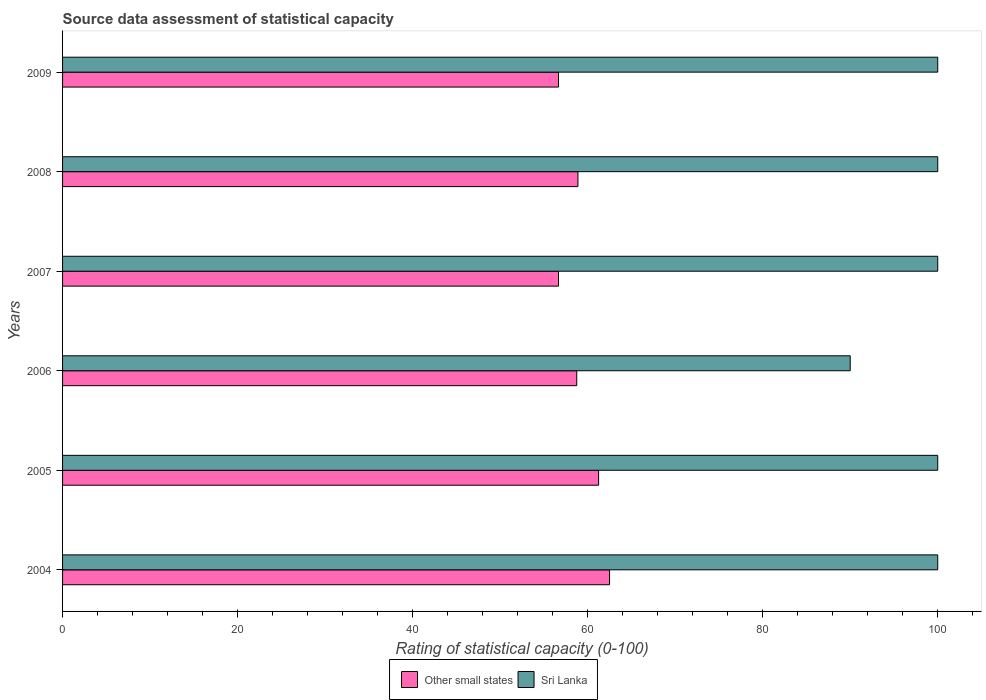How many different coloured bars are there?
Offer a very short reply. 2. How many groups of bars are there?
Your answer should be compact. 6. Are the number of bars per tick equal to the number of legend labels?
Provide a succinct answer. Yes. Are the number of bars on each tick of the Y-axis equal?
Offer a very short reply. Yes. In how many cases, is the number of bars for a given year not equal to the number of legend labels?
Your response must be concise. 0. What is the rating of statistical capacity in Sri Lanka in 2008?
Make the answer very short. 100. Across all years, what is the maximum rating of statistical capacity in Sri Lanka?
Ensure brevity in your answer.  100. Across all years, what is the minimum rating of statistical capacity in Other small states?
Keep it short and to the point. 56.67. What is the total rating of statistical capacity in Sri Lanka in the graph?
Offer a terse response. 590. What is the difference between the rating of statistical capacity in Other small states in 2008 and that in 2009?
Keep it short and to the point. 2.22. What is the difference between the rating of statistical capacity in Sri Lanka in 2006 and the rating of statistical capacity in Other small states in 2009?
Make the answer very short. 33.33. What is the average rating of statistical capacity in Other small states per year?
Your response must be concise. 59.12. In the year 2006, what is the difference between the rating of statistical capacity in Sri Lanka and rating of statistical capacity in Other small states?
Your answer should be compact. 31.25. In how many years, is the rating of statistical capacity in Other small states greater than 20 ?
Make the answer very short. 6. Is the rating of statistical capacity in Other small states in 2007 less than that in 2009?
Offer a very short reply. No. What is the difference between the highest and the lowest rating of statistical capacity in Sri Lanka?
Give a very brief answer. 10. In how many years, is the rating of statistical capacity in Sri Lanka greater than the average rating of statistical capacity in Sri Lanka taken over all years?
Make the answer very short. 5. Is the sum of the rating of statistical capacity in Sri Lanka in 2006 and 2008 greater than the maximum rating of statistical capacity in Other small states across all years?
Keep it short and to the point. Yes. What does the 2nd bar from the top in 2005 represents?
Your response must be concise. Other small states. What does the 2nd bar from the bottom in 2005 represents?
Your response must be concise. Sri Lanka. How many bars are there?
Give a very brief answer. 12. Are the values on the major ticks of X-axis written in scientific E-notation?
Your response must be concise. No. Where does the legend appear in the graph?
Your answer should be very brief. Bottom center. How many legend labels are there?
Keep it short and to the point. 2. What is the title of the graph?
Your response must be concise. Source data assessment of statistical capacity. Does "Sub-Saharan Africa (all income levels)" appear as one of the legend labels in the graph?
Keep it short and to the point. No. What is the label or title of the X-axis?
Offer a terse response. Rating of statistical capacity (0-100). What is the label or title of the Y-axis?
Offer a very short reply. Years. What is the Rating of statistical capacity (0-100) in Other small states in 2004?
Ensure brevity in your answer.  62.5. What is the Rating of statistical capacity (0-100) in Other small states in 2005?
Offer a terse response. 61.25. What is the Rating of statistical capacity (0-100) in Sri Lanka in 2005?
Your answer should be compact. 100. What is the Rating of statistical capacity (0-100) in Other small states in 2006?
Offer a very short reply. 58.75. What is the Rating of statistical capacity (0-100) of Sri Lanka in 2006?
Keep it short and to the point. 90. What is the Rating of statistical capacity (0-100) of Other small states in 2007?
Provide a succinct answer. 56.67. What is the Rating of statistical capacity (0-100) of Sri Lanka in 2007?
Keep it short and to the point. 100. What is the Rating of statistical capacity (0-100) in Other small states in 2008?
Your answer should be compact. 58.89. What is the Rating of statistical capacity (0-100) of Other small states in 2009?
Your answer should be very brief. 56.67. Across all years, what is the maximum Rating of statistical capacity (0-100) of Other small states?
Offer a terse response. 62.5. Across all years, what is the maximum Rating of statistical capacity (0-100) of Sri Lanka?
Make the answer very short. 100. Across all years, what is the minimum Rating of statistical capacity (0-100) of Other small states?
Your answer should be compact. 56.67. What is the total Rating of statistical capacity (0-100) in Other small states in the graph?
Offer a very short reply. 354.72. What is the total Rating of statistical capacity (0-100) of Sri Lanka in the graph?
Provide a short and direct response. 590. What is the difference between the Rating of statistical capacity (0-100) in Other small states in 2004 and that in 2006?
Offer a very short reply. 3.75. What is the difference between the Rating of statistical capacity (0-100) in Other small states in 2004 and that in 2007?
Make the answer very short. 5.83. What is the difference between the Rating of statistical capacity (0-100) of Sri Lanka in 2004 and that in 2007?
Keep it short and to the point. 0. What is the difference between the Rating of statistical capacity (0-100) of Other small states in 2004 and that in 2008?
Offer a very short reply. 3.61. What is the difference between the Rating of statistical capacity (0-100) in Sri Lanka in 2004 and that in 2008?
Provide a short and direct response. 0. What is the difference between the Rating of statistical capacity (0-100) in Other small states in 2004 and that in 2009?
Offer a very short reply. 5.83. What is the difference between the Rating of statistical capacity (0-100) of Sri Lanka in 2004 and that in 2009?
Offer a very short reply. 0. What is the difference between the Rating of statistical capacity (0-100) of Other small states in 2005 and that in 2006?
Provide a short and direct response. 2.5. What is the difference between the Rating of statistical capacity (0-100) in Sri Lanka in 2005 and that in 2006?
Your answer should be compact. 10. What is the difference between the Rating of statistical capacity (0-100) in Other small states in 2005 and that in 2007?
Offer a very short reply. 4.58. What is the difference between the Rating of statistical capacity (0-100) of Sri Lanka in 2005 and that in 2007?
Your answer should be compact. 0. What is the difference between the Rating of statistical capacity (0-100) in Other small states in 2005 and that in 2008?
Make the answer very short. 2.36. What is the difference between the Rating of statistical capacity (0-100) in Other small states in 2005 and that in 2009?
Provide a succinct answer. 4.58. What is the difference between the Rating of statistical capacity (0-100) of Other small states in 2006 and that in 2007?
Give a very brief answer. 2.08. What is the difference between the Rating of statistical capacity (0-100) in Other small states in 2006 and that in 2008?
Give a very brief answer. -0.14. What is the difference between the Rating of statistical capacity (0-100) of Sri Lanka in 2006 and that in 2008?
Ensure brevity in your answer.  -10. What is the difference between the Rating of statistical capacity (0-100) in Other small states in 2006 and that in 2009?
Offer a terse response. 2.08. What is the difference between the Rating of statistical capacity (0-100) of Sri Lanka in 2006 and that in 2009?
Offer a terse response. -10. What is the difference between the Rating of statistical capacity (0-100) in Other small states in 2007 and that in 2008?
Ensure brevity in your answer.  -2.22. What is the difference between the Rating of statistical capacity (0-100) in Sri Lanka in 2007 and that in 2009?
Your answer should be very brief. 0. What is the difference between the Rating of statistical capacity (0-100) of Other small states in 2008 and that in 2009?
Give a very brief answer. 2.22. What is the difference between the Rating of statistical capacity (0-100) in Sri Lanka in 2008 and that in 2009?
Give a very brief answer. 0. What is the difference between the Rating of statistical capacity (0-100) in Other small states in 2004 and the Rating of statistical capacity (0-100) in Sri Lanka in 2005?
Your answer should be very brief. -37.5. What is the difference between the Rating of statistical capacity (0-100) in Other small states in 2004 and the Rating of statistical capacity (0-100) in Sri Lanka in 2006?
Your answer should be very brief. -27.5. What is the difference between the Rating of statistical capacity (0-100) of Other small states in 2004 and the Rating of statistical capacity (0-100) of Sri Lanka in 2007?
Your answer should be very brief. -37.5. What is the difference between the Rating of statistical capacity (0-100) in Other small states in 2004 and the Rating of statistical capacity (0-100) in Sri Lanka in 2008?
Offer a terse response. -37.5. What is the difference between the Rating of statistical capacity (0-100) in Other small states in 2004 and the Rating of statistical capacity (0-100) in Sri Lanka in 2009?
Ensure brevity in your answer.  -37.5. What is the difference between the Rating of statistical capacity (0-100) in Other small states in 2005 and the Rating of statistical capacity (0-100) in Sri Lanka in 2006?
Make the answer very short. -28.75. What is the difference between the Rating of statistical capacity (0-100) in Other small states in 2005 and the Rating of statistical capacity (0-100) in Sri Lanka in 2007?
Your response must be concise. -38.75. What is the difference between the Rating of statistical capacity (0-100) in Other small states in 2005 and the Rating of statistical capacity (0-100) in Sri Lanka in 2008?
Ensure brevity in your answer.  -38.75. What is the difference between the Rating of statistical capacity (0-100) in Other small states in 2005 and the Rating of statistical capacity (0-100) in Sri Lanka in 2009?
Offer a terse response. -38.75. What is the difference between the Rating of statistical capacity (0-100) of Other small states in 2006 and the Rating of statistical capacity (0-100) of Sri Lanka in 2007?
Give a very brief answer. -41.25. What is the difference between the Rating of statistical capacity (0-100) of Other small states in 2006 and the Rating of statistical capacity (0-100) of Sri Lanka in 2008?
Your response must be concise. -41.25. What is the difference between the Rating of statistical capacity (0-100) in Other small states in 2006 and the Rating of statistical capacity (0-100) in Sri Lanka in 2009?
Your answer should be compact. -41.25. What is the difference between the Rating of statistical capacity (0-100) of Other small states in 2007 and the Rating of statistical capacity (0-100) of Sri Lanka in 2008?
Make the answer very short. -43.33. What is the difference between the Rating of statistical capacity (0-100) of Other small states in 2007 and the Rating of statistical capacity (0-100) of Sri Lanka in 2009?
Provide a succinct answer. -43.33. What is the difference between the Rating of statistical capacity (0-100) of Other small states in 2008 and the Rating of statistical capacity (0-100) of Sri Lanka in 2009?
Your answer should be very brief. -41.11. What is the average Rating of statistical capacity (0-100) in Other small states per year?
Offer a very short reply. 59.12. What is the average Rating of statistical capacity (0-100) of Sri Lanka per year?
Give a very brief answer. 98.33. In the year 2004, what is the difference between the Rating of statistical capacity (0-100) in Other small states and Rating of statistical capacity (0-100) in Sri Lanka?
Offer a terse response. -37.5. In the year 2005, what is the difference between the Rating of statistical capacity (0-100) of Other small states and Rating of statistical capacity (0-100) of Sri Lanka?
Provide a short and direct response. -38.75. In the year 2006, what is the difference between the Rating of statistical capacity (0-100) of Other small states and Rating of statistical capacity (0-100) of Sri Lanka?
Keep it short and to the point. -31.25. In the year 2007, what is the difference between the Rating of statistical capacity (0-100) in Other small states and Rating of statistical capacity (0-100) in Sri Lanka?
Ensure brevity in your answer.  -43.33. In the year 2008, what is the difference between the Rating of statistical capacity (0-100) in Other small states and Rating of statistical capacity (0-100) in Sri Lanka?
Keep it short and to the point. -41.11. In the year 2009, what is the difference between the Rating of statistical capacity (0-100) of Other small states and Rating of statistical capacity (0-100) of Sri Lanka?
Your answer should be compact. -43.33. What is the ratio of the Rating of statistical capacity (0-100) in Other small states in 2004 to that in 2005?
Your response must be concise. 1.02. What is the ratio of the Rating of statistical capacity (0-100) in Sri Lanka in 2004 to that in 2005?
Make the answer very short. 1. What is the ratio of the Rating of statistical capacity (0-100) of Other small states in 2004 to that in 2006?
Your answer should be very brief. 1.06. What is the ratio of the Rating of statistical capacity (0-100) of Other small states in 2004 to that in 2007?
Keep it short and to the point. 1.1. What is the ratio of the Rating of statistical capacity (0-100) in Sri Lanka in 2004 to that in 2007?
Offer a very short reply. 1. What is the ratio of the Rating of statistical capacity (0-100) of Other small states in 2004 to that in 2008?
Your response must be concise. 1.06. What is the ratio of the Rating of statistical capacity (0-100) of Sri Lanka in 2004 to that in 2008?
Provide a succinct answer. 1. What is the ratio of the Rating of statistical capacity (0-100) of Other small states in 2004 to that in 2009?
Ensure brevity in your answer.  1.1. What is the ratio of the Rating of statistical capacity (0-100) in Sri Lanka in 2004 to that in 2009?
Provide a short and direct response. 1. What is the ratio of the Rating of statistical capacity (0-100) of Other small states in 2005 to that in 2006?
Give a very brief answer. 1.04. What is the ratio of the Rating of statistical capacity (0-100) in Sri Lanka in 2005 to that in 2006?
Offer a very short reply. 1.11. What is the ratio of the Rating of statistical capacity (0-100) of Other small states in 2005 to that in 2007?
Offer a terse response. 1.08. What is the ratio of the Rating of statistical capacity (0-100) in Sri Lanka in 2005 to that in 2007?
Keep it short and to the point. 1. What is the ratio of the Rating of statistical capacity (0-100) in Other small states in 2005 to that in 2008?
Make the answer very short. 1.04. What is the ratio of the Rating of statistical capacity (0-100) in Sri Lanka in 2005 to that in 2008?
Your answer should be compact. 1. What is the ratio of the Rating of statistical capacity (0-100) of Other small states in 2005 to that in 2009?
Your answer should be very brief. 1.08. What is the ratio of the Rating of statistical capacity (0-100) of Other small states in 2006 to that in 2007?
Your answer should be very brief. 1.04. What is the ratio of the Rating of statistical capacity (0-100) in Other small states in 2006 to that in 2008?
Provide a succinct answer. 1. What is the ratio of the Rating of statistical capacity (0-100) in Other small states in 2006 to that in 2009?
Your answer should be compact. 1.04. What is the ratio of the Rating of statistical capacity (0-100) in Sri Lanka in 2006 to that in 2009?
Provide a succinct answer. 0.9. What is the ratio of the Rating of statistical capacity (0-100) of Other small states in 2007 to that in 2008?
Your response must be concise. 0.96. What is the ratio of the Rating of statistical capacity (0-100) of Other small states in 2007 to that in 2009?
Give a very brief answer. 1. What is the ratio of the Rating of statistical capacity (0-100) in Sri Lanka in 2007 to that in 2009?
Your response must be concise. 1. What is the ratio of the Rating of statistical capacity (0-100) in Other small states in 2008 to that in 2009?
Ensure brevity in your answer.  1.04. What is the ratio of the Rating of statistical capacity (0-100) of Sri Lanka in 2008 to that in 2009?
Give a very brief answer. 1. What is the difference between the highest and the second highest Rating of statistical capacity (0-100) of Other small states?
Give a very brief answer. 1.25. What is the difference between the highest and the second highest Rating of statistical capacity (0-100) of Sri Lanka?
Your answer should be very brief. 0. What is the difference between the highest and the lowest Rating of statistical capacity (0-100) of Other small states?
Provide a succinct answer. 5.83. 